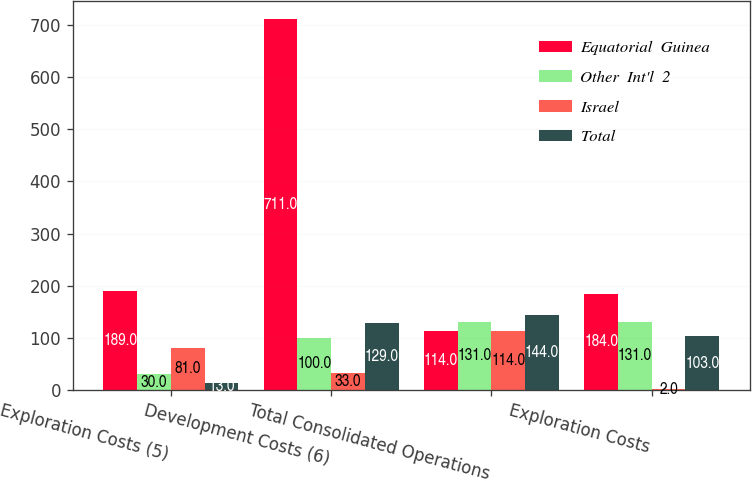Convert chart. <chart><loc_0><loc_0><loc_500><loc_500><stacked_bar_chart><ecel><fcel>Exploration Costs (5)<fcel>Development Costs (6)<fcel>Total Consolidated Operations<fcel>Exploration Costs<nl><fcel>Equatorial  Guinea<fcel>189<fcel>711<fcel>114<fcel>184<nl><fcel>Other  Int'l  2<fcel>30<fcel>100<fcel>131<fcel>131<nl><fcel>Israel<fcel>81<fcel>33<fcel>114<fcel>2<nl><fcel>Total<fcel>13<fcel>129<fcel>144<fcel>103<nl></chart> 